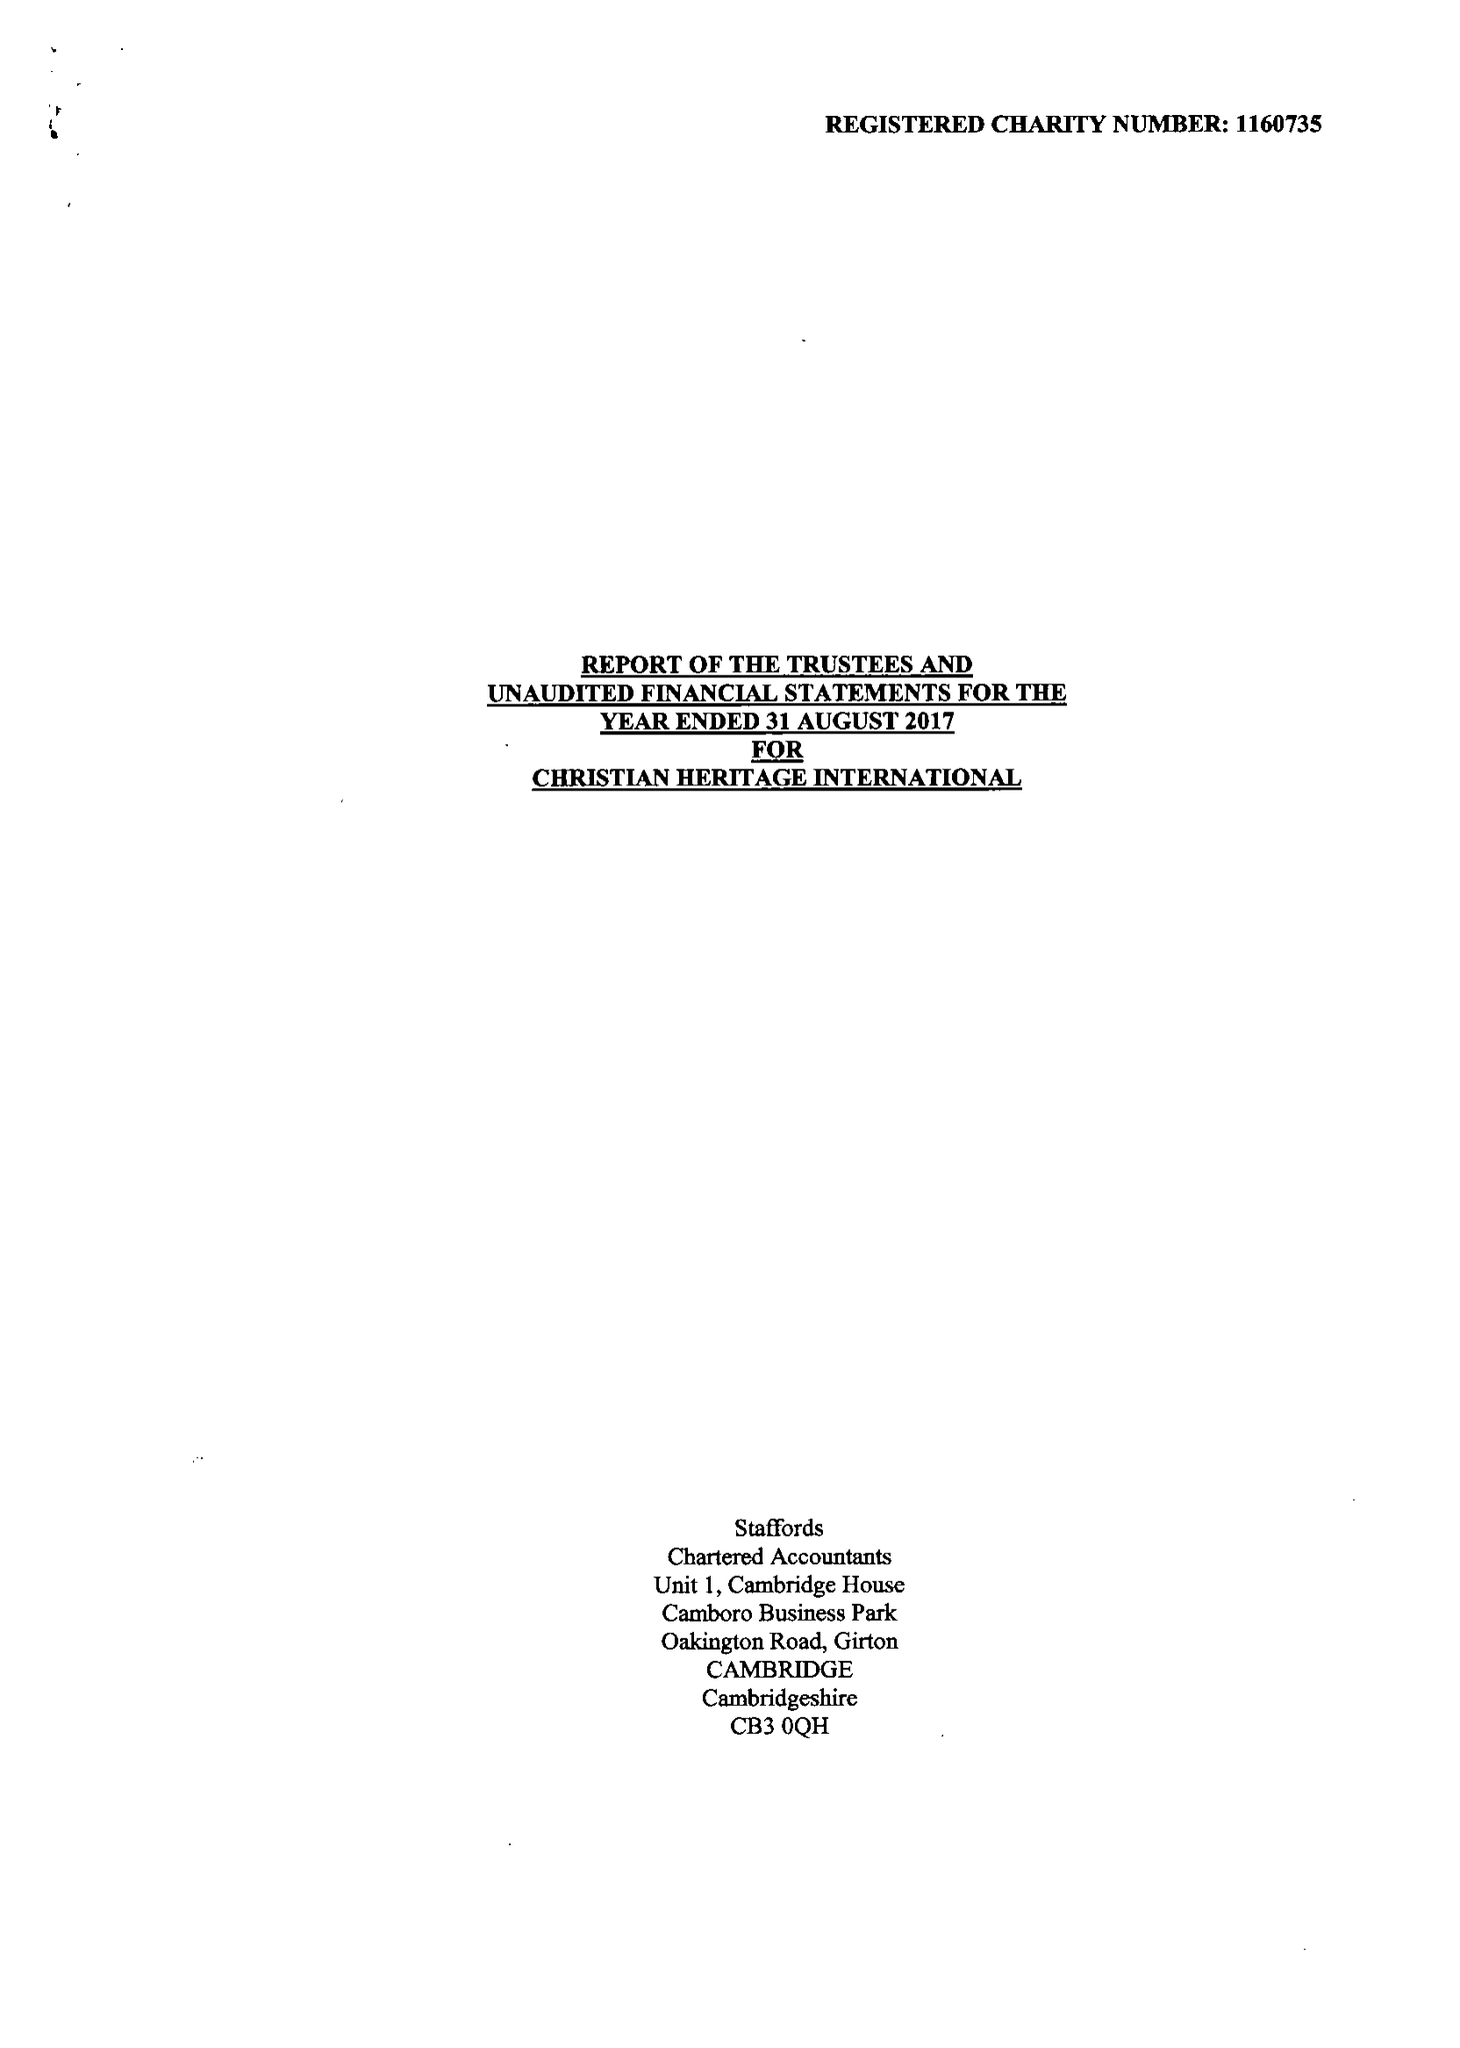What is the value for the charity_number?
Answer the question using a single word or phrase. 1160735 